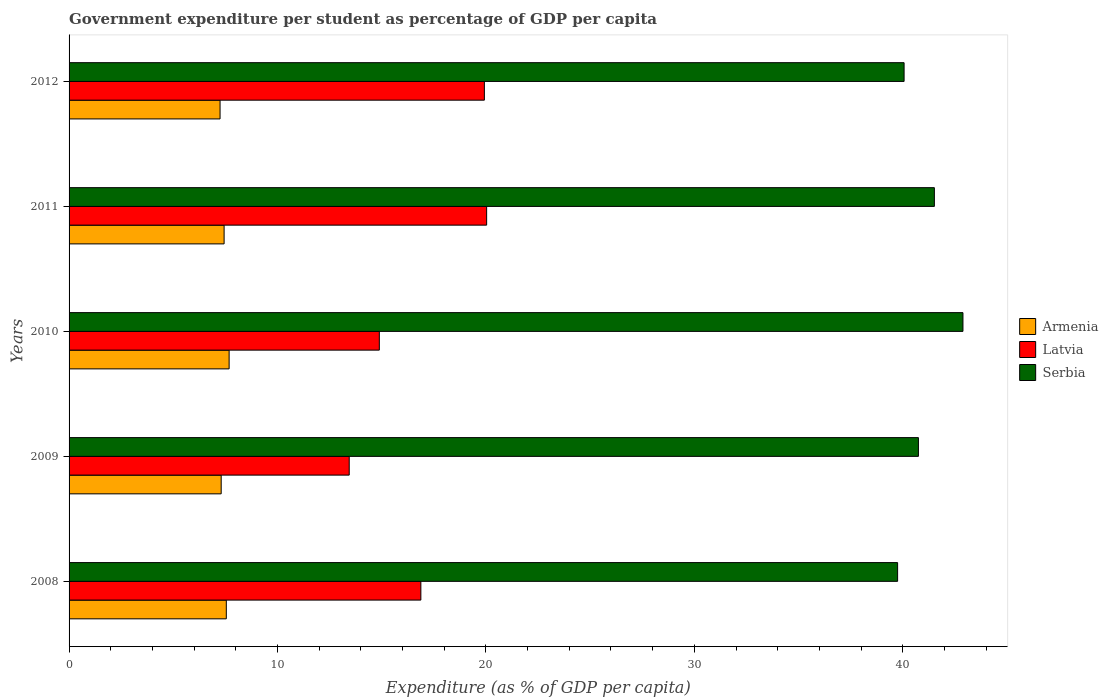How many different coloured bars are there?
Your response must be concise. 3. Are the number of bars on each tick of the Y-axis equal?
Provide a short and direct response. Yes. How many bars are there on the 1st tick from the bottom?
Provide a short and direct response. 3. In how many cases, is the number of bars for a given year not equal to the number of legend labels?
Provide a succinct answer. 0. What is the percentage of expenditure per student in Latvia in 2008?
Offer a terse response. 16.88. Across all years, what is the maximum percentage of expenditure per student in Serbia?
Give a very brief answer. 42.89. Across all years, what is the minimum percentage of expenditure per student in Latvia?
Provide a succinct answer. 13.44. What is the total percentage of expenditure per student in Armenia in the graph?
Provide a short and direct response. 37.2. What is the difference between the percentage of expenditure per student in Armenia in 2010 and that in 2012?
Make the answer very short. 0.43. What is the difference between the percentage of expenditure per student in Serbia in 2010 and the percentage of expenditure per student in Armenia in 2008?
Your answer should be compact. 35.34. What is the average percentage of expenditure per student in Serbia per year?
Provide a short and direct response. 40.99. In the year 2010, what is the difference between the percentage of expenditure per student in Serbia and percentage of expenditure per student in Armenia?
Your response must be concise. 35.21. What is the ratio of the percentage of expenditure per student in Serbia in 2009 to that in 2012?
Your answer should be very brief. 1.02. What is the difference between the highest and the second highest percentage of expenditure per student in Serbia?
Offer a very short reply. 1.37. What is the difference between the highest and the lowest percentage of expenditure per student in Armenia?
Ensure brevity in your answer.  0.43. Is the sum of the percentage of expenditure per student in Serbia in 2010 and 2012 greater than the maximum percentage of expenditure per student in Latvia across all years?
Keep it short and to the point. Yes. What does the 1st bar from the top in 2011 represents?
Provide a short and direct response. Serbia. What does the 2nd bar from the bottom in 2010 represents?
Offer a very short reply. Latvia. Is it the case that in every year, the sum of the percentage of expenditure per student in Latvia and percentage of expenditure per student in Armenia is greater than the percentage of expenditure per student in Serbia?
Your answer should be compact. No. How many bars are there?
Keep it short and to the point. 15. Are all the bars in the graph horizontal?
Provide a succinct answer. Yes. Are the values on the major ticks of X-axis written in scientific E-notation?
Your response must be concise. No. Does the graph contain any zero values?
Your answer should be compact. No. Does the graph contain grids?
Give a very brief answer. No. Where does the legend appear in the graph?
Provide a succinct answer. Center right. How many legend labels are there?
Your answer should be compact. 3. What is the title of the graph?
Your answer should be very brief. Government expenditure per student as percentage of GDP per capita. What is the label or title of the X-axis?
Give a very brief answer. Expenditure (as % of GDP per capita). What is the label or title of the Y-axis?
Provide a short and direct response. Years. What is the Expenditure (as % of GDP per capita) in Armenia in 2008?
Your response must be concise. 7.54. What is the Expenditure (as % of GDP per capita) in Latvia in 2008?
Your answer should be very brief. 16.88. What is the Expenditure (as % of GDP per capita) of Serbia in 2008?
Give a very brief answer. 39.75. What is the Expenditure (as % of GDP per capita) in Armenia in 2009?
Your response must be concise. 7.3. What is the Expenditure (as % of GDP per capita) of Latvia in 2009?
Give a very brief answer. 13.44. What is the Expenditure (as % of GDP per capita) in Serbia in 2009?
Your answer should be very brief. 40.75. What is the Expenditure (as % of GDP per capita) in Armenia in 2010?
Your response must be concise. 7.68. What is the Expenditure (as % of GDP per capita) in Latvia in 2010?
Give a very brief answer. 14.89. What is the Expenditure (as % of GDP per capita) in Serbia in 2010?
Provide a short and direct response. 42.89. What is the Expenditure (as % of GDP per capita) in Armenia in 2011?
Provide a short and direct response. 7.44. What is the Expenditure (as % of GDP per capita) of Latvia in 2011?
Offer a very short reply. 20.03. What is the Expenditure (as % of GDP per capita) of Serbia in 2011?
Provide a short and direct response. 41.52. What is the Expenditure (as % of GDP per capita) in Armenia in 2012?
Keep it short and to the point. 7.24. What is the Expenditure (as % of GDP per capita) of Latvia in 2012?
Your answer should be compact. 19.93. What is the Expenditure (as % of GDP per capita) of Serbia in 2012?
Make the answer very short. 40.06. Across all years, what is the maximum Expenditure (as % of GDP per capita) in Armenia?
Ensure brevity in your answer.  7.68. Across all years, what is the maximum Expenditure (as % of GDP per capita) of Latvia?
Keep it short and to the point. 20.03. Across all years, what is the maximum Expenditure (as % of GDP per capita) in Serbia?
Make the answer very short. 42.89. Across all years, what is the minimum Expenditure (as % of GDP per capita) in Armenia?
Give a very brief answer. 7.24. Across all years, what is the minimum Expenditure (as % of GDP per capita) of Latvia?
Provide a succinct answer. 13.44. Across all years, what is the minimum Expenditure (as % of GDP per capita) of Serbia?
Offer a terse response. 39.75. What is the total Expenditure (as % of GDP per capita) in Armenia in the graph?
Give a very brief answer. 37.2. What is the total Expenditure (as % of GDP per capita) in Latvia in the graph?
Offer a very short reply. 85.17. What is the total Expenditure (as % of GDP per capita) of Serbia in the graph?
Offer a terse response. 204.97. What is the difference between the Expenditure (as % of GDP per capita) of Armenia in 2008 and that in 2009?
Make the answer very short. 0.25. What is the difference between the Expenditure (as % of GDP per capita) in Latvia in 2008 and that in 2009?
Provide a succinct answer. 3.44. What is the difference between the Expenditure (as % of GDP per capita) in Serbia in 2008 and that in 2009?
Provide a short and direct response. -1. What is the difference between the Expenditure (as % of GDP per capita) in Armenia in 2008 and that in 2010?
Keep it short and to the point. -0.14. What is the difference between the Expenditure (as % of GDP per capita) of Latvia in 2008 and that in 2010?
Keep it short and to the point. 1.99. What is the difference between the Expenditure (as % of GDP per capita) of Serbia in 2008 and that in 2010?
Offer a very short reply. -3.14. What is the difference between the Expenditure (as % of GDP per capita) in Armenia in 2008 and that in 2011?
Your answer should be very brief. 0.11. What is the difference between the Expenditure (as % of GDP per capita) of Latvia in 2008 and that in 2011?
Offer a terse response. -3.16. What is the difference between the Expenditure (as % of GDP per capita) of Serbia in 2008 and that in 2011?
Your answer should be very brief. -1.76. What is the difference between the Expenditure (as % of GDP per capita) in Armenia in 2008 and that in 2012?
Your response must be concise. 0.3. What is the difference between the Expenditure (as % of GDP per capita) in Latvia in 2008 and that in 2012?
Keep it short and to the point. -3.05. What is the difference between the Expenditure (as % of GDP per capita) of Serbia in 2008 and that in 2012?
Offer a terse response. -0.31. What is the difference between the Expenditure (as % of GDP per capita) in Armenia in 2009 and that in 2010?
Offer a very short reply. -0.38. What is the difference between the Expenditure (as % of GDP per capita) of Latvia in 2009 and that in 2010?
Ensure brevity in your answer.  -1.44. What is the difference between the Expenditure (as % of GDP per capita) in Serbia in 2009 and that in 2010?
Ensure brevity in your answer.  -2.14. What is the difference between the Expenditure (as % of GDP per capita) in Armenia in 2009 and that in 2011?
Make the answer very short. -0.14. What is the difference between the Expenditure (as % of GDP per capita) of Latvia in 2009 and that in 2011?
Give a very brief answer. -6.59. What is the difference between the Expenditure (as % of GDP per capita) in Serbia in 2009 and that in 2011?
Your response must be concise. -0.77. What is the difference between the Expenditure (as % of GDP per capita) of Armenia in 2009 and that in 2012?
Your answer should be compact. 0.05. What is the difference between the Expenditure (as % of GDP per capita) in Latvia in 2009 and that in 2012?
Offer a terse response. -6.48. What is the difference between the Expenditure (as % of GDP per capita) in Serbia in 2009 and that in 2012?
Ensure brevity in your answer.  0.69. What is the difference between the Expenditure (as % of GDP per capita) of Armenia in 2010 and that in 2011?
Your answer should be compact. 0.24. What is the difference between the Expenditure (as % of GDP per capita) of Latvia in 2010 and that in 2011?
Provide a short and direct response. -5.15. What is the difference between the Expenditure (as % of GDP per capita) in Serbia in 2010 and that in 2011?
Offer a terse response. 1.37. What is the difference between the Expenditure (as % of GDP per capita) of Armenia in 2010 and that in 2012?
Offer a very short reply. 0.43. What is the difference between the Expenditure (as % of GDP per capita) in Latvia in 2010 and that in 2012?
Your answer should be compact. -5.04. What is the difference between the Expenditure (as % of GDP per capita) in Serbia in 2010 and that in 2012?
Offer a very short reply. 2.82. What is the difference between the Expenditure (as % of GDP per capita) in Armenia in 2011 and that in 2012?
Keep it short and to the point. 0.19. What is the difference between the Expenditure (as % of GDP per capita) of Latvia in 2011 and that in 2012?
Provide a succinct answer. 0.11. What is the difference between the Expenditure (as % of GDP per capita) in Serbia in 2011 and that in 2012?
Make the answer very short. 1.45. What is the difference between the Expenditure (as % of GDP per capita) in Armenia in 2008 and the Expenditure (as % of GDP per capita) in Latvia in 2009?
Provide a succinct answer. -5.9. What is the difference between the Expenditure (as % of GDP per capita) of Armenia in 2008 and the Expenditure (as % of GDP per capita) of Serbia in 2009?
Give a very brief answer. -33.21. What is the difference between the Expenditure (as % of GDP per capita) of Latvia in 2008 and the Expenditure (as % of GDP per capita) of Serbia in 2009?
Your response must be concise. -23.87. What is the difference between the Expenditure (as % of GDP per capita) in Armenia in 2008 and the Expenditure (as % of GDP per capita) in Latvia in 2010?
Make the answer very short. -7.34. What is the difference between the Expenditure (as % of GDP per capita) of Armenia in 2008 and the Expenditure (as % of GDP per capita) of Serbia in 2010?
Keep it short and to the point. -35.34. What is the difference between the Expenditure (as % of GDP per capita) of Latvia in 2008 and the Expenditure (as % of GDP per capita) of Serbia in 2010?
Ensure brevity in your answer.  -26.01. What is the difference between the Expenditure (as % of GDP per capita) of Armenia in 2008 and the Expenditure (as % of GDP per capita) of Latvia in 2011?
Offer a very short reply. -12.49. What is the difference between the Expenditure (as % of GDP per capita) of Armenia in 2008 and the Expenditure (as % of GDP per capita) of Serbia in 2011?
Give a very brief answer. -33.97. What is the difference between the Expenditure (as % of GDP per capita) in Latvia in 2008 and the Expenditure (as % of GDP per capita) in Serbia in 2011?
Provide a short and direct response. -24.64. What is the difference between the Expenditure (as % of GDP per capita) in Armenia in 2008 and the Expenditure (as % of GDP per capita) in Latvia in 2012?
Offer a very short reply. -12.38. What is the difference between the Expenditure (as % of GDP per capita) of Armenia in 2008 and the Expenditure (as % of GDP per capita) of Serbia in 2012?
Your answer should be compact. -32.52. What is the difference between the Expenditure (as % of GDP per capita) in Latvia in 2008 and the Expenditure (as % of GDP per capita) in Serbia in 2012?
Provide a short and direct response. -23.18. What is the difference between the Expenditure (as % of GDP per capita) of Armenia in 2009 and the Expenditure (as % of GDP per capita) of Latvia in 2010?
Provide a succinct answer. -7.59. What is the difference between the Expenditure (as % of GDP per capita) of Armenia in 2009 and the Expenditure (as % of GDP per capita) of Serbia in 2010?
Provide a succinct answer. -35.59. What is the difference between the Expenditure (as % of GDP per capita) in Latvia in 2009 and the Expenditure (as % of GDP per capita) in Serbia in 2010?
Offer a very short reply. -29.45. What is the difference between the Expenditure (as % of GDP per capita) in Armenia in 2009 and the Expenditure (as % of GDP per capita) in Latvia in 2011?
Keep it short and to the point. -12.74. What is the difference between the Expenditure (as % of GDP per capita) in Armenia in 2009 and the Expenditure (as % of GDP per capita) in Serbia in 2011?
Provide a succinct answer. -34.22. What is the difference between the Expenditure (as % of GDP per capita) of Latvia in 2009 and the Expenditure (as % of GDP per capita) of Serbia in 2011?
Your response must be concise. -28.07. What is the difference between the Expenditure (as % of GDP per capita) in Armenia in 2009 and the Expenditure (as % of GDP per capita) in Latvia in 2012?
Your answer should be compact. -12.63. What is the difference between the Expenditure (as % of GDP per capita) of Armenia in 2009 and the Expenditure (as % of GDP per capita) of Serbia in 2012?
Ensure brevity in your answer.  -32.76. What is the difference between the Expenditure (as % of GDP per capita) of Latvia in 2009 and the Expenditure (as % of GDP per capita) of Serbia in 2012?
Make the answer very short. -26.62. What is the difference between the Expenditure (as % of GDP per capita) of Armenia in 2010 and the Expenditure (as % of GDP per capita) of Latvia in 2011?
Offer a terse response. -12.36. What is the difference between the Expenditure (as % of GDP per capita) of Armenia in 2010 and the Expenditure (as % of GDP per capita) of Serbia in 2011?
Your response must be concise. -33.84. What is the difference between the Expenditure (as % of GDP per capita) in Latvia in 2010 and the Expenditure (as % of GDP per capita) in Serbia in 2011?
Give a very brief answer. -26.63. What is the difference between the Expenditure (as % of GDP per capita) in Armenia in 2010 and the Expenditure (as % of GDP per capita) in Latvia in 2012?
Your response must be concise. -12.25. What is the difference between the Expenditure (as % of GDP per capita) of Armenia in 2010 and the Expenditure (as % of GDP per capita) of Serbia in 2012?
Offer a very short reply. -32.38. What is the difference between the Expenditure (as % of GDP per capita) in Latvia in 2010 and the Expenditure (as % of GDP per capita) in Serbia in 2012?
Offer a terse response. -25.18. What is the difference between the Expenditure (as % of GDP per capita) in Armenia in 2011 and the Expenditure (as % of GDP per capita) in Latvia in 2012?
Your answer should be very brief. -12.49. What is the difference between the Expenditure (as % of GDP per capita) in Armenia in 2011 and the Expenditure (as % of GDP per capita) in Serbia in 2012?
Make the answer very short. -32.62. What is the difference between the Expenditure (as % of GDP per capita) in Latvia in 2011 and the Expenditure (as % of GDP per capita) in Serbia in 2012?
Your answer should be compact. -20.03. What is the average Expenditure (as % of GDP per capita) of Armenia per year?
Your answer should be compact. 7.44. What is the average Expenditure (as % of GDP per capita) in Latvia per year?
Your answer should be very brief. 17.03. What is the average Expenditure (as % of GDP per capita) in Serbia per year?
Your answer should be compact. 40.99. In the year 2008, what is the difference between the Expenditure (as % of GDP per capita) of Armenia and Expenditure (as % of GDP per capita) of Latvia?
Provide a succinct answer. -9.33. In the year 2008, what is the difference between the Expenditure (as % of GDP per capita) of Armenia and Expenditure (as % of GDP per capita) of Serbia?
Your response must be concise. -32.21. In the year 2008, what is the difference between the Expenditure (as % of GDP per capita) of Latvia and Expenditure (as % of GDP per capita) of Serbia?
Keep it short and to the point. -22.87. In the year 2009, what is the difference between the Expenditure (as % of GDP per capita) in Armenia and Expenditure (as % of GDP per capita) in Latvia?
Make the answer very short. -6.14. In the year 2009, what is the difference between the Expenditure (as % of GDP per capita) in Armenia and Expenditure (as % of GDP per capita) in Serbia?
Offer a very short reply. -33.45. In the year 2009, what is the difference between the Expenditure (as % of GDP per capita) of Latvia and Expenditure (as % of GDP per capita) of Serbia?
Offer a terse response. -27.31. In the year 2010, what is the difference between the Expenditure (as % of GDP per capita) in Armenia and Expenditure (as % of GDP per capita) in Latvia?
Keep it short and to the point. -7.21. In the year 2010, what is the difference between the Expenditure (as % of GDP per capita) in Armenia and Expenditure (as % of GDP per capita) in Serbia?
Your answer should be very brief. -35.21. In the year 2010, what is the difference between the Expenditure (as % of GDP per capita) in Latvia and Expenditure (as % of GDP per capita) in Serbia?
Offer a terse response. -28. In the year 2011, what is the difference between the Expenditure (as % of GDP per capita) in Armenia and Expenditure (as % of GDP per capita) in Latvia?
Your answer should be compact. -12.6. In the year 2011, what is the difference between the Expenditure (as % of GDP per capita) of Armenia and Expenditure (as % of GDP per capita) of Serbia?
Offer a terse response. -34.08. In the year 2011, what is the difference between the Expenditure (as % of GDP per capita) in Latvia and Expenditure (as % of GDP per capita) in Serbia?
Provide a short and direct response. -21.48. In the year 2012, what is the difference between the Expenditure (as % of GDP per capita) of Armenia and Expenditure (as % of GDP per capita) of Latvia?
Keep it short and to the point. -12.68. In the year 2012, what is the difference between the Expenditure (as % of GDP per capita) in Armenia and Expenditure (as % of GDP per capita) in Serbia?
Keep it short and to the point. -32.82. In the year 2012, what is the difference between the Expenditure (as % of GDP per capita) of Latvia and Expenditure (as % of GDP per capita) of Serbia?
Give a very brief answer. -20.14. What is the ratio of the Expenditure (as % of GDP per capita) in Armenia in 2008 to that in 2009?
Your answer should be compact. 1.03. What is the ratio of the Expenditure (as % of GDP per capita) in Latvia in 2008 to that in 2009?
Give a very brief answer. 1.26. What is the ratio of the Expenditure (as % of GDP per capita) of Serbia in 2008 to that in 2009?
Ensure brevity in your answer.  0.98. What is the ratio of the Expenditure (as % of GDP per capita) in Armenia in 2008 to that in 2010?
Provide a succinct answer. 0.98. What is the ratio of the Expenditure (as % of GDP per capita) in Latvia in 2008 to that in 2010?
Your answer should be very brief. 1.13. What is the ratio of the Expenditure (as % of GDP per capita) in Serbia in 2008 to that in 2010?
Offer a terse response. 0.93. What is the ratio of the Expenditure (as % of GDP per capita) of Armenia in 2008 to that in 2011?
Provide a succinct answer. 1.01. What is the ratio of the Expenditure (as % of GDP per capita) in Latvia in 2008 to that in 2011?
Your answer should be very brief. 0.84. What is the ratio of the Expenditure (as % of GDP per capita) of Serbia in 2008 to that in 2011?
Provide a short and direct response. 0.96. What is the ratio of the Expenditure (as % of GDP per capita) in Armenia in 2008 to that in 2012?
Provide a short and direct response. 1.04. What is the ratio of the Expenditure (as % of GDP per capita) of Latvia in 2008 to that in 2012?
Make the answer very short. 0.85. What is the ratio of the Expenditure (as % of GDP per capita) of Serbia in 2008 to that in 2012?
Your response must be concise. 0.99. What is the ratio of the Expenditure (as % of GDP per capita) in Armenia in 2009 to that in 2010?
Ensure brevity in your answer.  0.95. What is the ratio of the Expenditure (as % of GDP per capita) of Latvia in 2009 to that in 2010?
Your answer should be very brief. 0.9. What is the ratio of the Expenditure (as % of GDP per capita) in Serbia in 2009 to that in 2010?
Provide a succinct answer. 0.95. What is the ratio of the Expenditure (as % of GDP per capita) in Armenia in 2009 to that in 2011?
Provide a short and direct response. 0.98. What is the ratio of the Expenditure (as % of GDP per capita) of Latvia in 2009 to that in 2011?
Your answer should be compact. 0.67. What is the ratio of the Expenditure (as % of GDP per capita) in Serbia in 2009 to that in 2011?
Your response must be concise. 0.98. What is the ratio of the Expenditure (as % of GDP per capita) of Armenia in 2009 to that in 2012?
Provide a succinct answer. 1.01. What is the ratio of the Expenditure (as % of GDP per capita) in Latvia in 2009 to that in 2012?
Provide a succinct answer. 0.67. What is the ratio of the Expenditure (as % of GDP per capita) of Serbia in 2009 to that in 2012?
Give a very brief answer. 1.02. What is the ratio of the Expenditure (as % of GDP per capita) of Armenia in 2010 to that in 2011?
Ensure brevity in your answer.  1.03. What is the ratio of the Expenditure (as % of GDP per capita) in Latvia in 2010 to that in 2011?
Ensure brevity in your answer.  0.74. What is the ratio of the Expenditure (as % of GDP per capita) of Serbia in 2010 to that in 2011?
Your answer should be very brief. 1.03. What is the ratio of the Expenditure (as % of GDP per capita) of Armenia in 2010 to that in 2012?
Ensure brevity in your answer.  1.06. What is the ratio of the Expenditure (as % of GDP per capita) of Latvia in 2010 to that in 2012?
Offer a very short reply. 0.75. What is the ratio of the Expenditure (as % of GDP per capita) in Serbia in 2010 to that in 2012?
Your answer should be very brief. 1.07. What is the ratio of the Expenditure (as % of GDP per capita) in Armenia in 2011 to that in 2012?
Your response must be concise. 1.03. What is the ratio of the Expenditure (as % of GDP per capita) in Serbia in 2011 to that in 2012?
Your answer should be very brief. 1.04. What is the difference between the highest and the second highest Expenditure (as % of GDP per capita) of Armenia?
Provide a succinct answer. 0.14. What is the difference between the highest and the second highest Expenditure (as % of GDP per capita) in Latvia?
Ensure brevity in your answer.  0.11. What is the difference between the highest and the second highest Expenditure (as % of GDP per capita) of Serbia?
Give a very brief answer. 1.37. What is the difference between the highest and the lowest Expenditure (as % of GDP per capita) of Armenia?
Make the answer very short. 0.43. What is the difference between the highest and the lowest Expenditure (as % of GDP per capita) in Latvia?
Offer a very short reply. 6.59. What is the difference between the highest and the lowest Expenditure (as % of GDP per capita) in Serbia?
Offer a terse response. 3.14. 